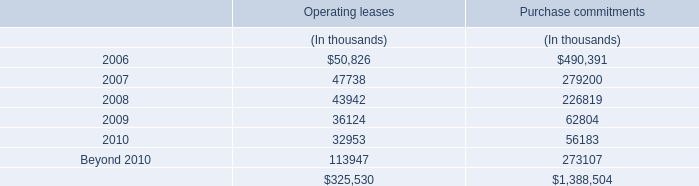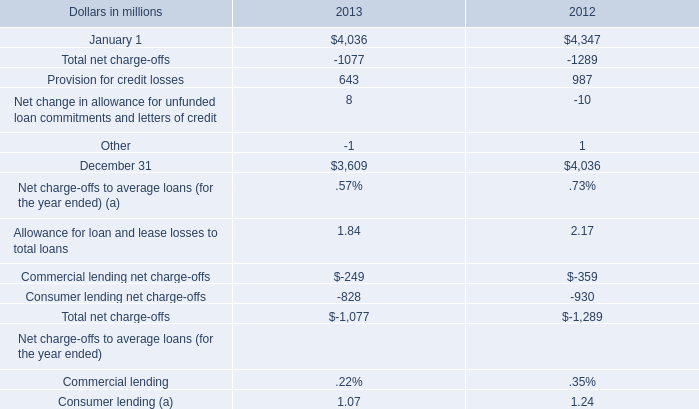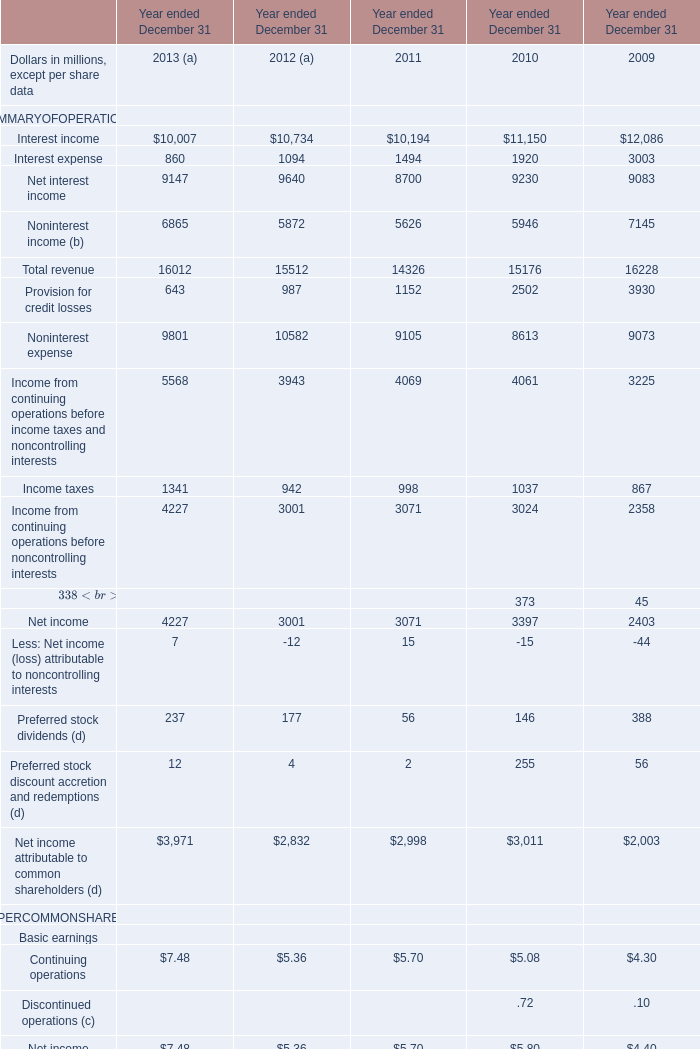What's the sum of January 1 of 2013, and Interest income of Year ended December 31 2009 ? 
Computations: (4036.0 + 12086.0)
Answer: 16122.0. 